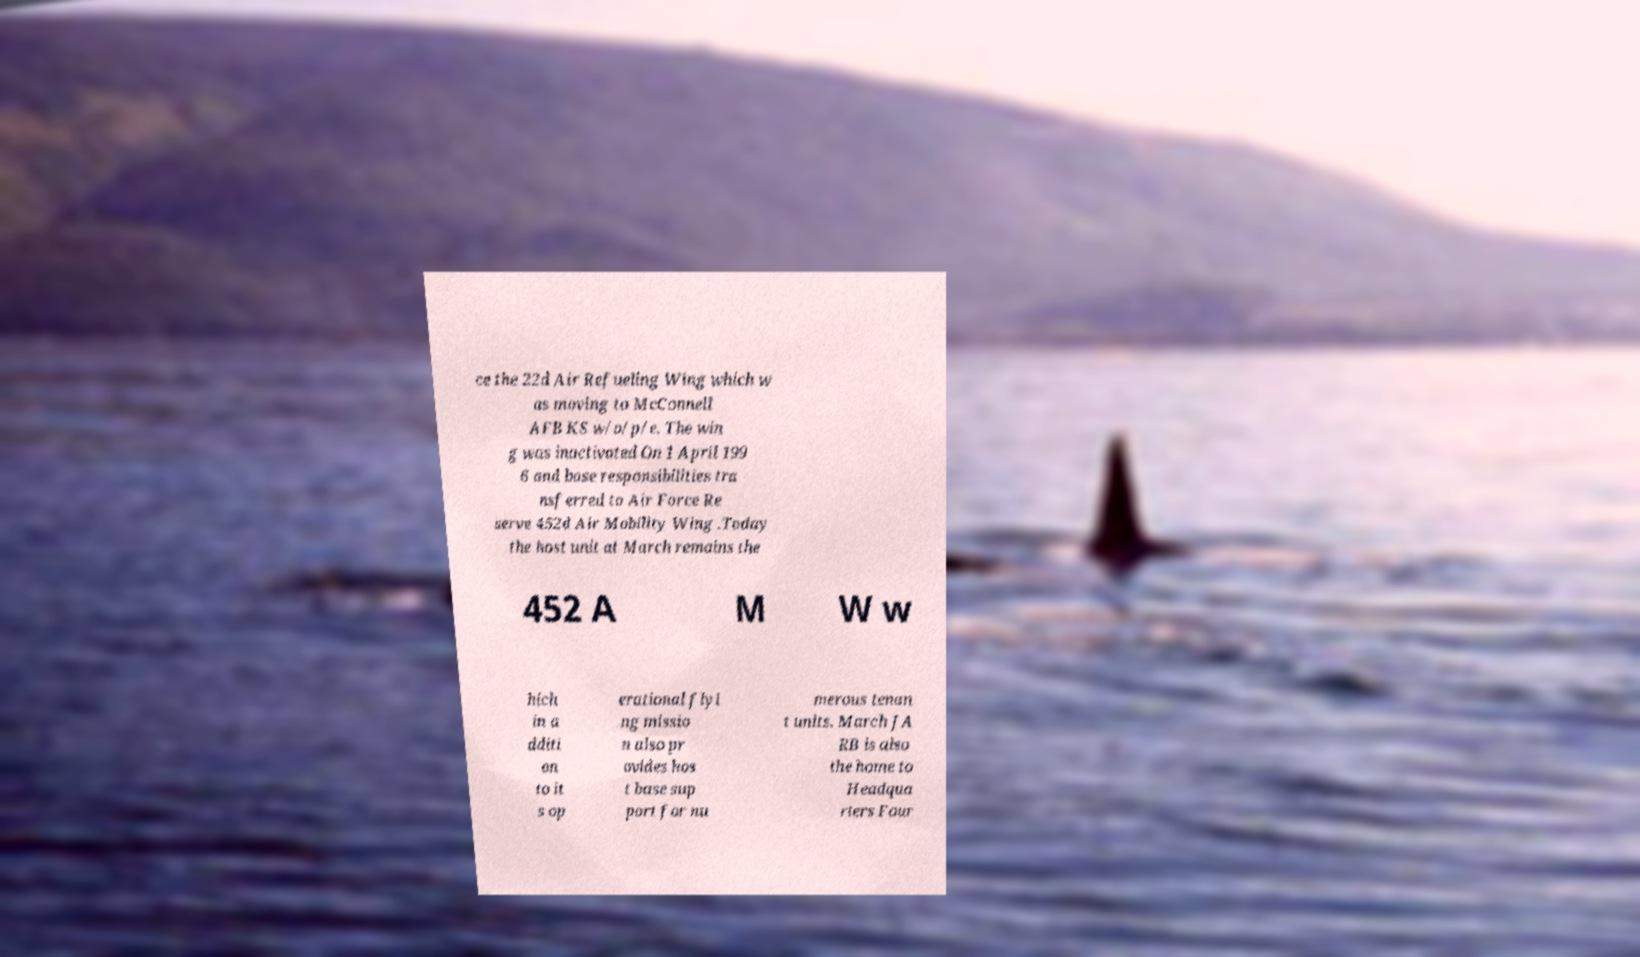What messages or text are displayed in this image? I need them in a readable, typed format. ce the 22d Air Refueling Wing which w as moving to McConnell AFB KS w/o/p/e. The win g was inactivated On 1 April 199 6 and base responsibilities tra nsferred to Air Force Re serve 452d Air Mobility Wing .Today the host unit at March remains the 452 A M W w hich in a dditi on to it s op erational flyi ng missio n also pr ovides hos t base sup port for nu merous tenan t units. March JA RB is also the home to Headqua rters Four 